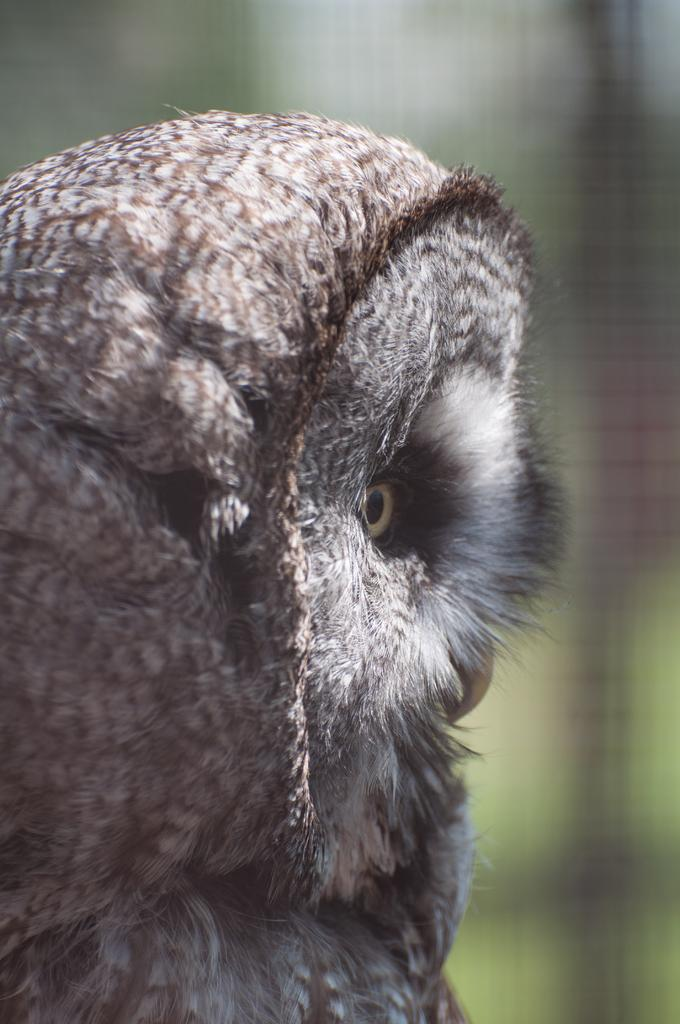What type of animal is in the image? There is a bird in the image. Can you describe the bird's coloring? The bird has brown and cream colors. What can be observed about the background of the image? The background of the image is blurred. Is the bird wearing a crown in the image? No, the bird is not wearing a crown in the image. What type of boat can be seen in the image? There is no boat present in the image. 